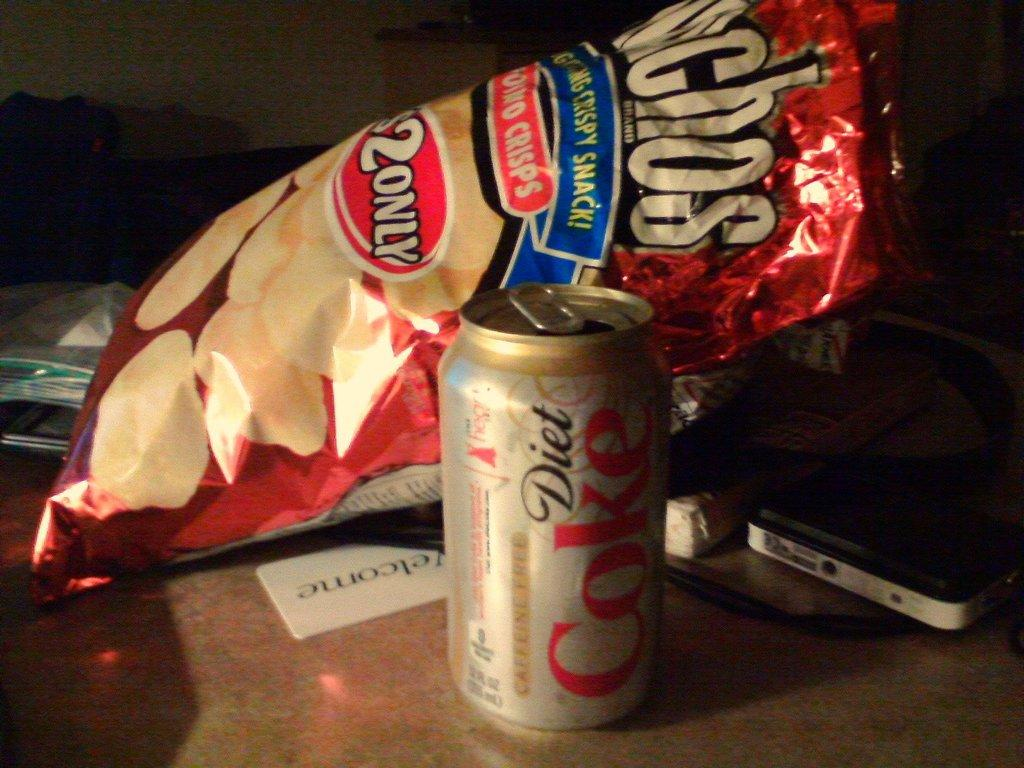Provide a one-sentence caption for the provided image. Next to the can of diet Coke is a bag of chips. 